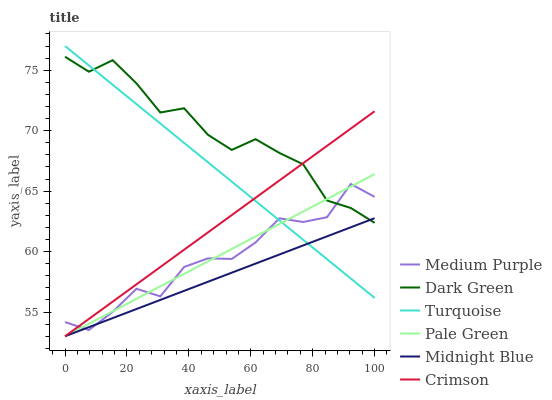Does Midnight Blue have the minimum area under the curve?
Answer yes or no. Yes. Does Dark Green have the maximum area under the curve?
Answer yes or no. Yes. Does Medium Purple have the minimum area under the curve?
Answer yes or no. No. Does Medium Purple have the maximum area under the curve?
Answer yes or no. No. Is Pale Green the smoothest?
Answer yes or no. Yes. Is Medium Purple the roughest?
Answer yes or no. Yes. Is Midnight Blue the smoothest?
Answer yes or no. No. Is Midnight Blue the roughest?
Answer yes or no. No. Does Midnight Blue have the lowest value?
Answer yes or no. Yes. Does Medium Purple have the lowest value?
Answer yes or no. No. Does Turquoise have the highest value?
Answer yes or no. Yes. Does Medium Purple have the highest value?
Answer yes or no. No. Does Midnight Blue intersect Turquoise?
Answer yes or no. Yes. Is Midnight Blue less than Turquoise?
Answer yes or no. No. Is Midnight Blue greater than Turquoise?
Answer yes or no. No. 